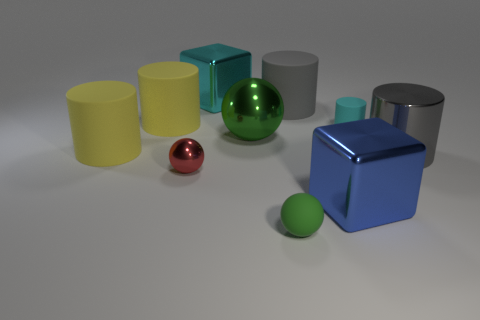Subtract 1 cylinders. How many cylinders are left? 4 Subtract all cyan cylinders. How many cylinders are left? 4 Subtract all big metal cylinders. How many cylinders are left? 4 Subtract all cyan cylinders. Subtract all gray spheres. How many cylinders are left? 4 Subtract all balls. How many objects are left? 7 Add 3 big gray matte objects. How many big gray matte objects exist? 4 Subtract 0 purple cubes. How many objects are left? 10 Subtract all cyan shiny objects. Subtract all red shiny balls. How many objects are left? 8 Add 1 small red balls. How many small red balls are left? 2 